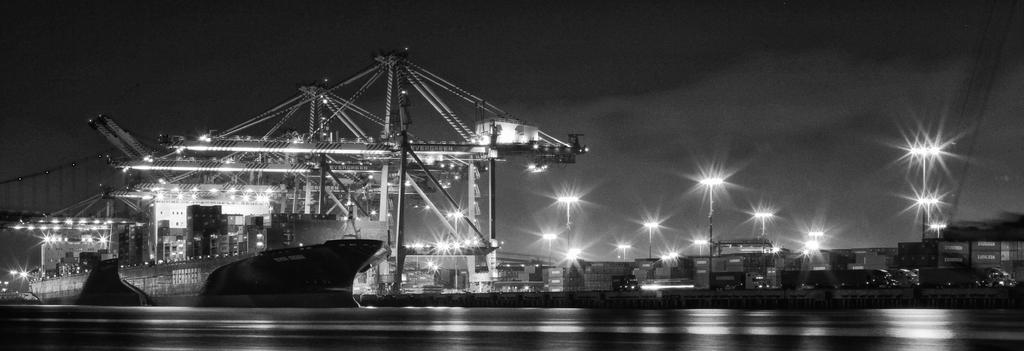What type of location is depicted in the image? There is a shipyard in the image. What materials are used for the structures in the shipyard? Metal structures are present in the shipyard. What type of lighting is available in the shipyard? Lamp posts are visible in the image. What type of storage units are present in the shipyard? Containers are present in the shipyard. What type of vehicles are present in the shipyard? Ships are present in the shipyard. What type of punishment does the tiger receive in the image? There is no tiger present in the image, so no punishment can be observed. 